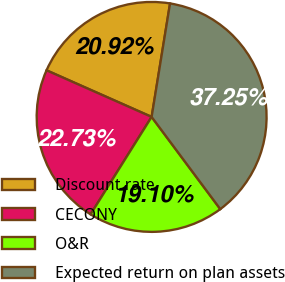Convert chart to OTSL. <chart><loc_0><loc_0><loc_500><loc_500><pie_chart><fcel>Discount rate<fcel>CECONY<fcel>O&R<fcel>Expected return on plan assets<nl><fcel>20.92%<fcel>22.73%<fcel>19.1%<fcel>37.25%<nl></chart> 